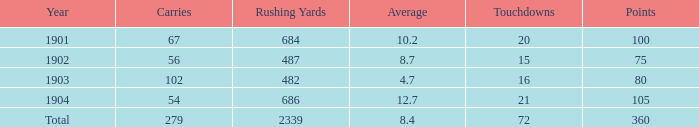What is the average count of carries possessing over 72 touchdowns? None. Can you parse all the data within this table? {'header': ['Year', 'Carries', 'Rushing Yards', 'Average', 'Touchdowns', 'Points'], 'rows': [['1901', '67', '684', '10.2', '20', '100'], ['1902', '56', '487', '8.7', '15', '75'], ['1903', '102', '482', '4.7', '16', '80'], ['1904', '54', '686', '12.7', '21', '105'], ['Total', '279', '2339', '8.4', '72', '360']]} 